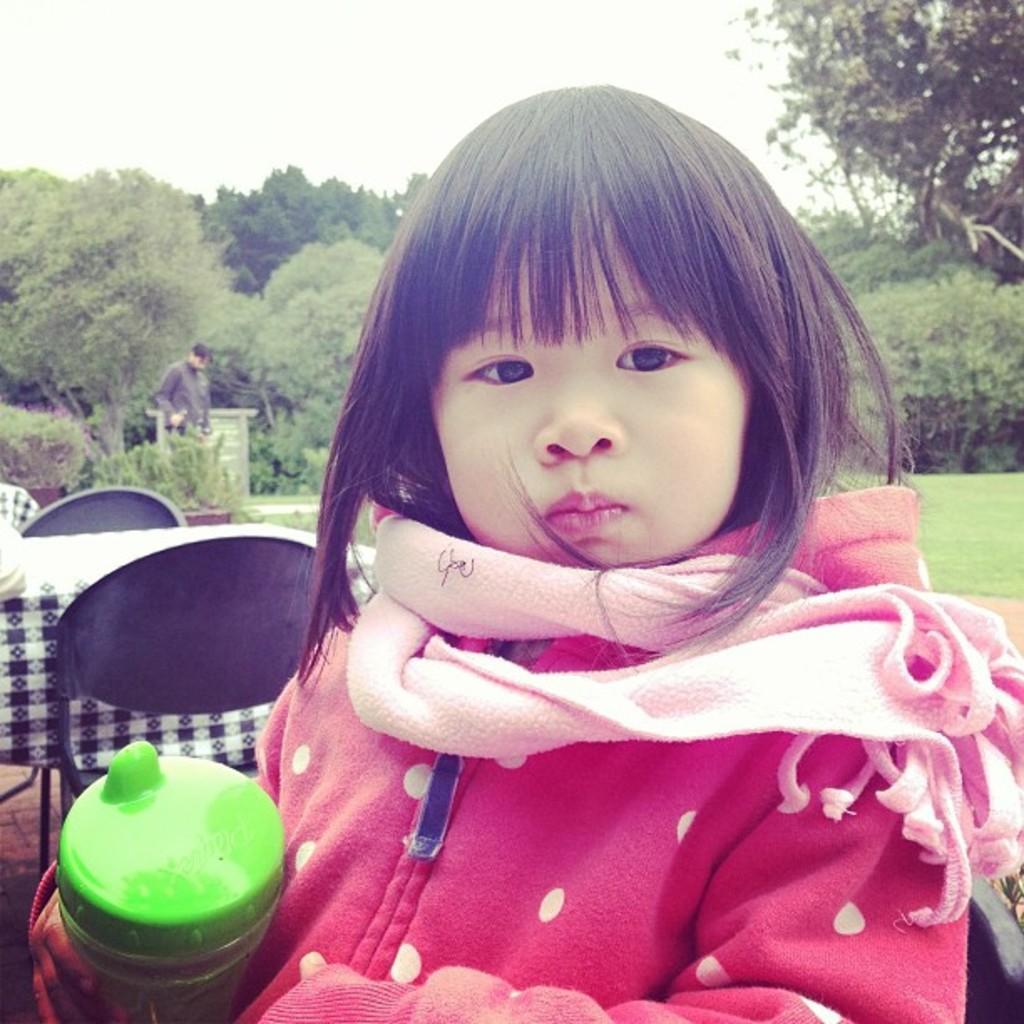Describe this image in one or two sentences. At the bottom of this image, there is a girl in red color jacket, holding a bottle with a hand and having a scarf. In the background, there are trees, a person, there are trees, plants and grass on the ground and there are clouds in the sky. 